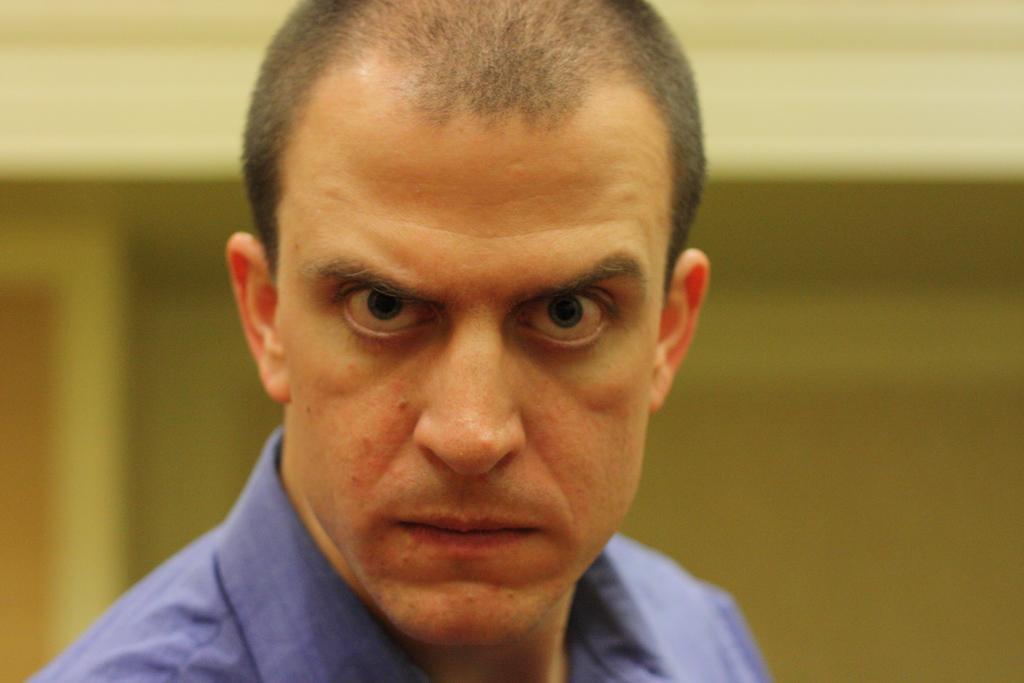Please provide a concise description of this image. This picture seems to be clicked inside. In the foreground there is a person wearing blue color shirt. In the background there is a wall. 